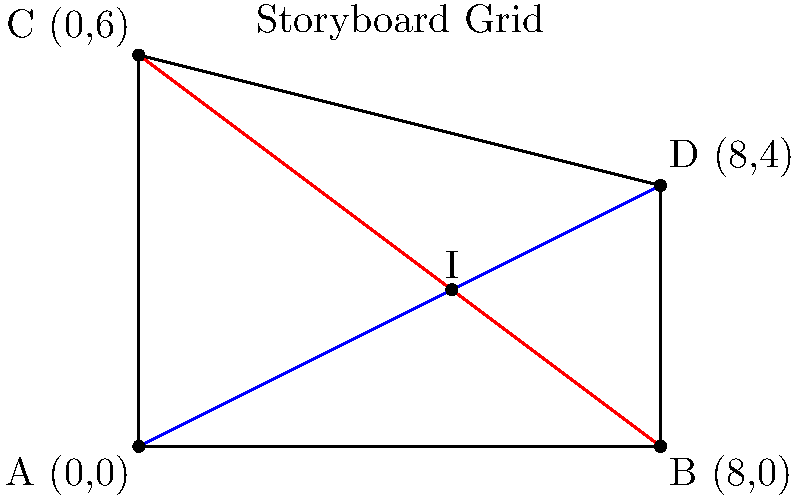In your storyboard grid, you've drawn two diagonal lines representing camera movements. The blue line goes from point A (0,0) to point D (8,4), while the red line goes from point B (8,0) to point C (0,6). At what coordinates do these two camera movement lines intersect? To find the intersection point of the two lines, we need to follow these steps:

1) First, let's find the equations of both lines:

   For line AD (blue):
   Slope = $(4-0)/(8-0) = 1/2$
   Equation: $y = \frac{1}{2}x$

   For line BC (red):
   Slope = $(6-0)/(0-8) = -3/4$
   Equation: $y = -\frac{3}{4}x + 6$

2) At the intersection point, the x and y coordinates will satisfy both equations. So we can set them equal:

   $\frac{1}{2}x = -\frac{3}{4}x + 6$

3) Solve for x:
   $\frac{1}{2}x + \frac{3}{4}x = 6$
   $\frac{5}{4}x = 6$
   $x = \frac{24}{5} = 4.8$

4) Substitute this x-value back into either of the original equations to find y. Let's use the first equation:

   $y = \frac{1}{2}(4.8) = 2.4$

5) Therefore, the intersection point is at (4.8, 2.4).

This point represents where the two camera movements cross in your storyboard grid.
Answer: (4.8, 2.4) 